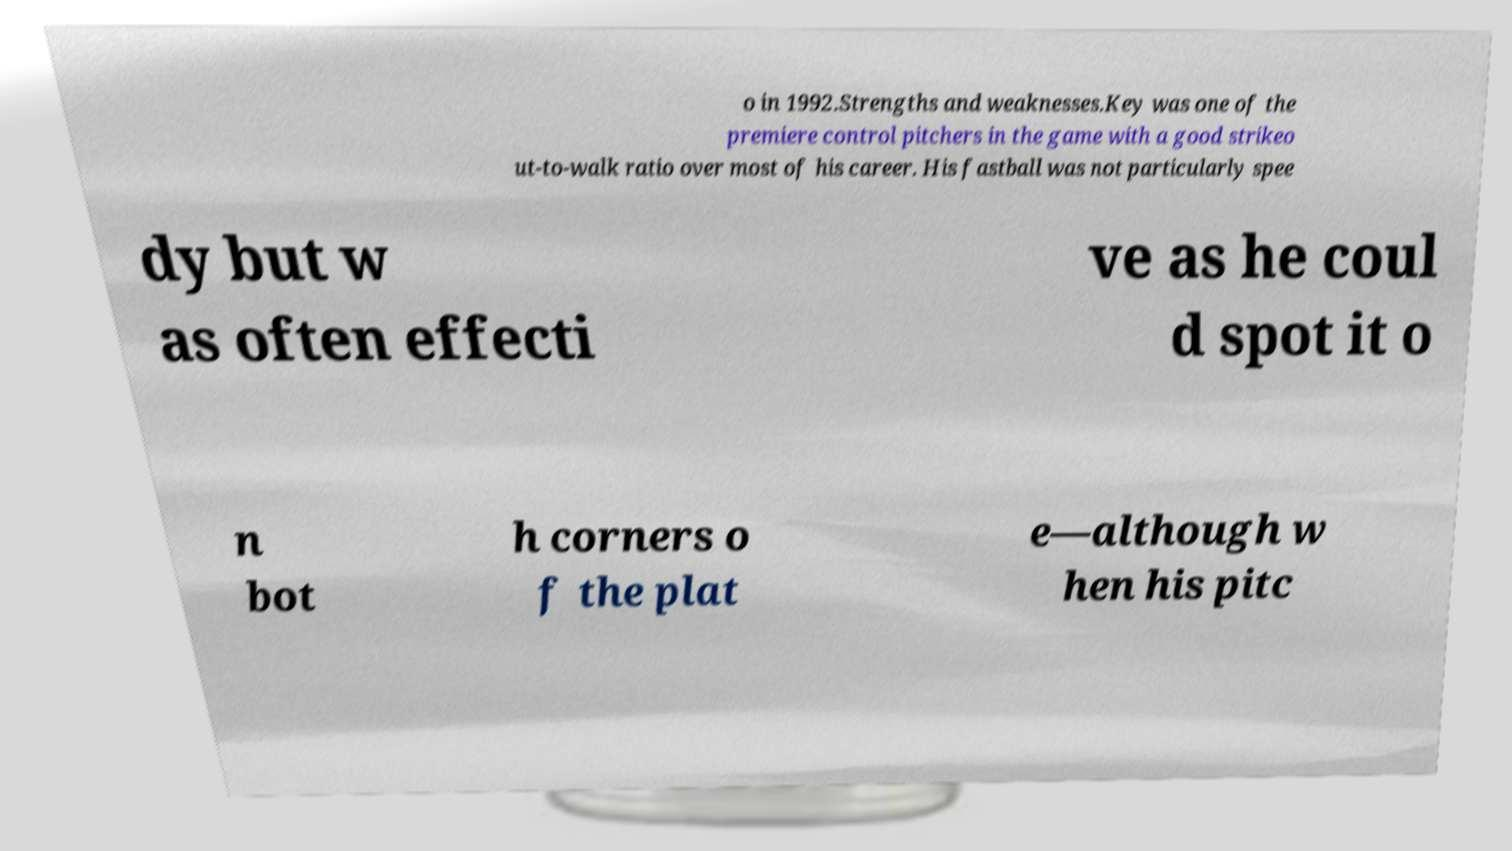Can you read and provide the text displayed in the image?This photo seems to have some interesting text. Can you extract and type it out for me? o in 1992.Strengths and weaknesses.Key was one of the premiere control pitchers in the game with a good strikeo ut-to-walk ratio over most of his career. His fastball was not particularly spee dy but w as often effecti ve as he coul d spot it o n bot h corners o f the plat e—although w hen his pitc 